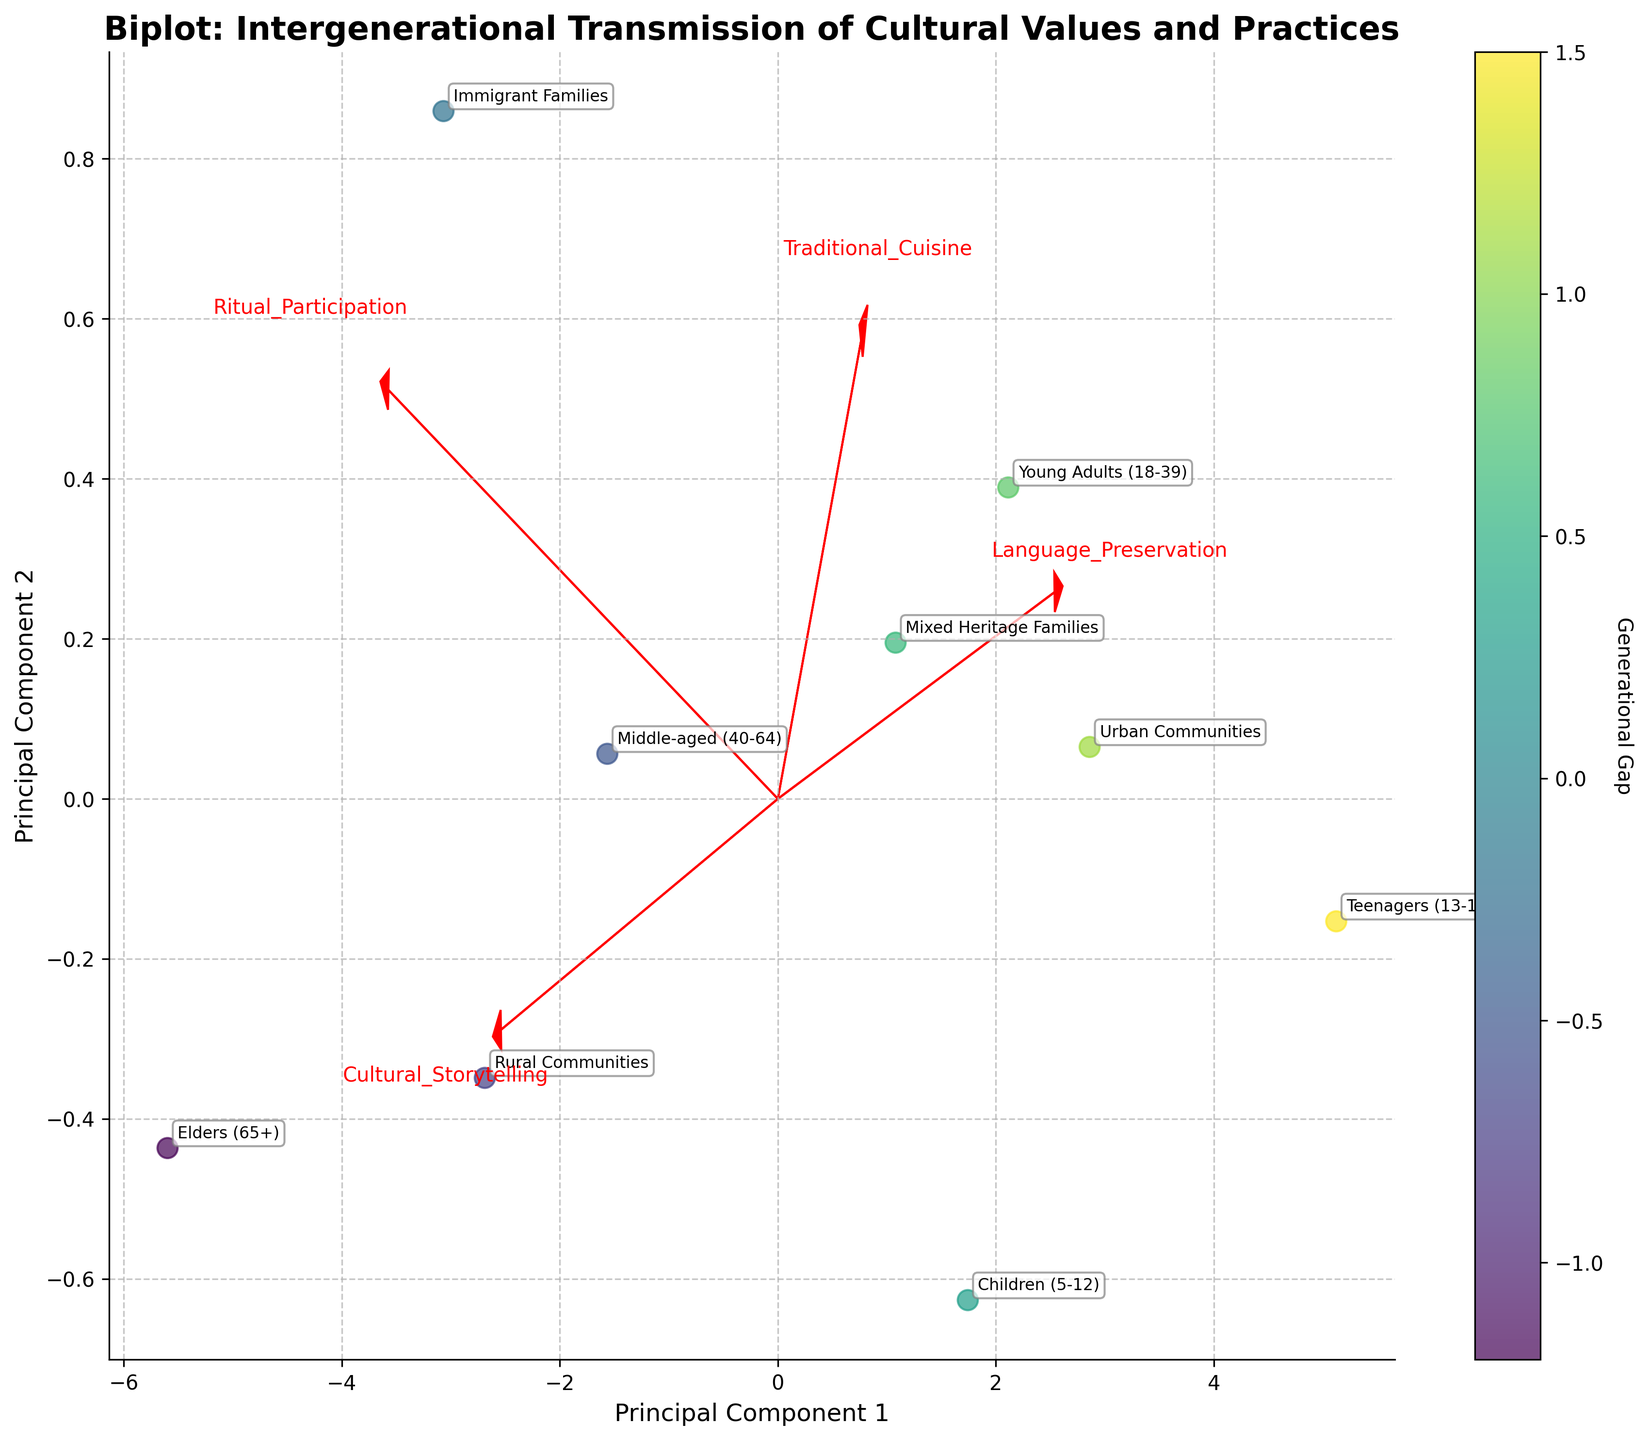What does the title of the figure indicate? The title of the figure, "Biplot: Intergenerational Transmission of Cultural Values and Practices," suggests that it visualizes the relationship between different generations and their cultural values and practices. This implies a comparison across generational groups regarding how cultural values and practices are preserved or transmitted.
Answer: It indicates a comparison of cultural values and practices across generations What do the arrow vectors in the plot represent? The arrow vectors in the plot represent the features (Cultural Storytelling, Traditional Cuisine, Language Preservation, Ritual Participation) projected into the Principal Component space. Their direction and length show how much each feature contributes to the principal components (PC1 and PC2).
Answer: They represent the features' contributions to the principal components Which generational group is closest to the origin in the biplot? By looking at the plot, the "Teenagers (13-17)" group seems to be closest to the origin, which might suggest they are less strongly associated with the principal components compared to other groups.
Answer: Teenagers (13-17) Which group has the highest 'Generational Gap' value? The colorbar indicates the 'Generational Gap'. The color intensity helps to identify that "Teenagers (13-17)" have the highest 'Generational Gap' value.
Answer: Teenagers (13-17) How does the "Elders (65+)" group compare to "Young Adults (18-39)" in terms of PC1 and PC2? The "Elders (65+)" group is further along both PC1 and PC2 compared to the "Young Adults (18-39)" group, suggesting that 'Elders' have higher values of the identified features than 'Young Adults.'
Answer: Elders are higher on both PC1 and PC2 How does the plot distinguish between urban and rural communities? Urban and rural communities are represented by different data points. Rural Communities have higher values on both PC1 and PC2 compared to Urban Communities, indicating stronger association with the cultural practices and values identified.
Answer: Rural communities score higher on PC1 and PC2 Which generational group seems most strongly associated with "Language Preservation"? The direction and length of the "Language Preservation" arrow vector help identify that the "Elders (65+)" group is closely aligned, indicating a strong association with this cultural practice.
Answer: Elders (65+) What is the relationship between "Generational Gap" and PC1? Observing the color gradient along PC1, we notice that groups with a higher value on PC1 tend to have lower (more negative) values of 'Generational Gap', contrary to groups lower on PC1. This suggests an inverse relationship.
Answer: Inverse relationship Which two groups have a similar value on PC2 but different values on PC1? "Elders (65+)" and "Immigrant Families" show a similar value on PC2, yet "Elders (65+)" are much higher on PC1 compared to "Immigrant Families." This suggests differing associations with primary cultural values and practices.
Answer: Elders (65+) and Immigrant Families 